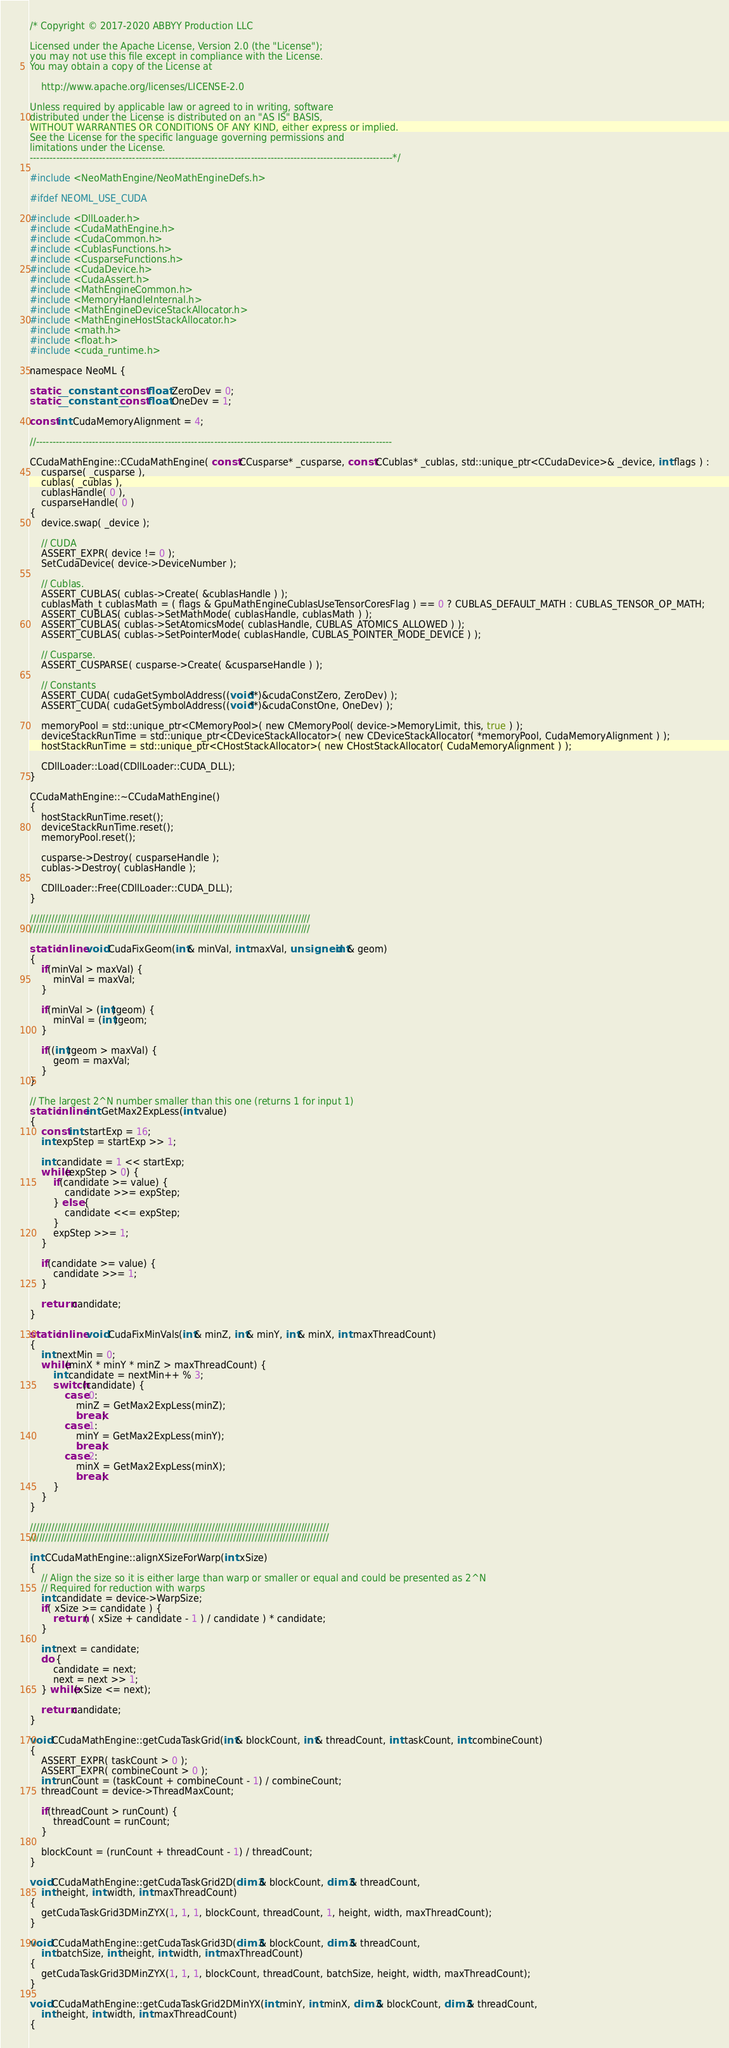<code> <loc_0><loc_0><loc_500><loc_500><_Cuda_>/* Copyright © 2017-2020 ABBYY Production LLC

Licensed under the Apache License, Version 2.0 (the "License");
you may not use this file except in compliance with the License.
You may obtain a copy of the License at

	http://www.apache.org/licenses/LICENSE-2.0

Unless required by applicable law or agreed to in writing, software
distributed under the License is distributed on an "AS IS" BASIS,
WITHOUT WARRANTIES OR CONDITIONS OF ANY KIND, either express or implied.
See the License for the specific language governing permissions and
limitations under the License.
--------------------------------------------------------------------------------------------------------------*/

#include <NeoMathEngine/NeoMathEngineDefs.h>

#ifdef NEOML_USE_CUDA

#include <DllLoader.h>
#include <CudaMathEngine.h>
#include <CudaCommon.h>
#include <CublasFunctions.h>
#include <CusparseFunctions.h>
#include <CudaDevice.h>
#include <CudaAssert.h>
#include <MathEngineCommon.h>
#include <MemoryHandleInternal.h>
#include <MathEngineDeviceStackAllocator.h>
#include <MathEngineHostStackAllocator.h>
#include <math.h>
#include <float.h>
#include <cuda_runtime.h>

namespace NeoML {

static __constant__ const float ZeroDev = 0;
static __constant__ const float OneDev = 1;

const int CudaMemoryAlignment = 4;

//------------------------------------------------------------------------------------------------------------

CCudaMathEngine::CCudaMathEngine( const CCusparse* _cusparse, const CCublas* _cublas, std::unique_ptr<CCudaDevice>& _device, int flags ) :
	cusparse( _cusparse ),
	cublas( _cublas ),
	cublasHandle( 0 ),
	cusparseHandle( 0 )
{
	device.swap( _device );

	// CUDA
	ASSERT_EXPR( device != 0 );
	SetCudaDevice( device->DeviceNumber );

	// Cublas.
	ASSERT_CUBLAS( cublas->Create( &cublasHandle ) );
	cublasMath_t cublasMath = ( flags & GpuMathEngineCublasUseTensorCoresFlag ) == 0 ? CUBLAS_DEFAULT_MATH : CUBLAS_TENSOR_OP_MATH;
	ASSERT_CUBLAS( cublas->SetMathMode( cublasHandle, cublasMath ) );
	ASSERT_CUBLAS( cublas->SetAtomicsMode( cublasHandle, CUBLAS_ATOMICS_ALLOWED ) );
	ASSERT_CUBLAS( cublas->SetPointerMode( cublasHandle, CUBLAS_POINTER_MODE_DEVICE ) );

	// Cusparse.
	ASSERT_CUSPARSE( cusparse->Create( &cusparseHandle ) );

	// Constants
	ASSERT_CUDA( cudaGetSymbolAddress((void**)&cudaConstZero, ZeroDev) );
	ASSERT_CUDA( cudaGetSymbolAddress((void**)&cudaConstOne, OneDev) );

	memoryPool = std::unique_ptr<CMemoryPool>( new CMemoryPool( device->MemoryLimit, this, true ) );
	deviceStackRunTime = std::unique_ptr<CDeviceStackAllocator>( new CDeviceStackAllocator( *memoryPool, CudaMemoryAlignment ) );
	hostStackRunTime = std::unique_ptr<CHostStackAllocator>( new CHostStackAllocator( CudaMemoryAlignment ) );

	CDllLoader::Load(CDllLoader::CUDA_DLL);
}

CCudaMathEngine::~CCudaMathEngine()
{
	hostStackRunTime.reset();
	deviceStackRunTime.reset();
	memoryPool.reset();

	cusparse->Destroy( cusparseHandle );
	cublas->Destroy( cublasHandle );

	CDllLoader::Free(CDllLoader::CUDA_DLL);
}

///////////////////////////////////////////////////////////////////////////////////////////
///////////////////////////////////////////////////////////////////////////////////////////

static inline void CudaFixGeom(int& minVal, int maxVal, unsigned int& geom)
{
	if(minVal > maxVal) {
		minVal = maxVal;
	}

	if(minVal > (int)geom) {
		minVal = (int)geom;
	}

	if((int)geom > maxVal) {
		geom = maxVal;
	}
}

// The largest 2^N number smaller than this one (returns 1 for input 1)
static inline int GetMax2ExpLess(int value)
{
	const int startExp = 16;
	int expStep = startExp >> 1;

	int candidate = 1 << startExp;
	while(expStep > 0) {
		if(candidate >= value) {
			candidate >>= expStep;
		} else {
			candidate <<= expStep;
		}
		expStep >>= 1;
	}

	if(candidate >= value) {
		candidate >>= 1;
	}

	return candidate;
}

static inline void CudaFixMinVals(int& minZ, int& minY, int& minX, int maxThreadCount)
{
	int nextMin = 0;
	while(minX * minY * minZ > maxThreadCount) {
		int candidate = nextMin++ % 3;
		switch(candidate) {
			case 0:
				minZ = GetMax2ExpLess(minZ);
				break;
			case 1:
				minY = GetMax2ExpLess(minY);
				break;
			case 2:
				minX = GetMax2ExpLess(minX);
				break;
		}
	}
}

/////////////////////////////////////////////////////////////////////////////////////////////////
/////////////////////////////////////////////////////////////////////////////////////////////////

int CCudaMathEngine::alignXSizeForWarp(int xSize)
{
	// Align the size so it is either large than warp or smaller or equal and could be presented as 2^N 
	// Required for reduction with warps
	int candidate = device->WarpSize;
	if( xSize >= candidate ) {
		return ( ( xSize + candidate - 1 ) / candidate ) * candidate;
	}

	int next = candidate;
	do {
		candidate = next;
		next = next >> 1;
	} while(xSize <= next);

	return candidate;
}

void CCudaMathEngine::getCudaTaskGrid(int& blockCount, int& threadCount, int taskCount, int combineCount)
{
	ASSERT_EXPR( taskCount > 0 );
	ASSERT_EXPR( combineCount > 0 );
	int runCount = (taskCount + combineCount - 1) / combineCount;
	threadCount = device->ThreadMaxCount;

	if(threadCount > runCount) {
		threadCount = runCount;
	}

	blockCount = (runCount + threadCount - 1) / threadCount;
}

void CCudaMathEngine::getCudaTaskGrid2D(dim3& blockCount, dim3& threadCount,
	int height, int width, int maxThreadCount)
{
	getCudaTaskGrid3DMinZYX(1, 1, 1, blockCount, threadCount, 1, height, width, maxThreadCount);
}

void CCudaMathEngine::getCudaTaskGrid3D(dim3& blockCount, dim3& threadCount,
	int batchSize, int height, int width, int maxThreadCount)
{
	getCudaTaskGrid3DMinZYX(1, 1, 1, blockCount, threadCount, batchSize, height, width, maxThreadCount);
}

void CCudaMathEngine::getCudaTaskGrid2DMinYX(int minY, int minX, dim3& blockCount, dim3& threadCount,
	int height, int width, int maxThreadCount)
{</code> 